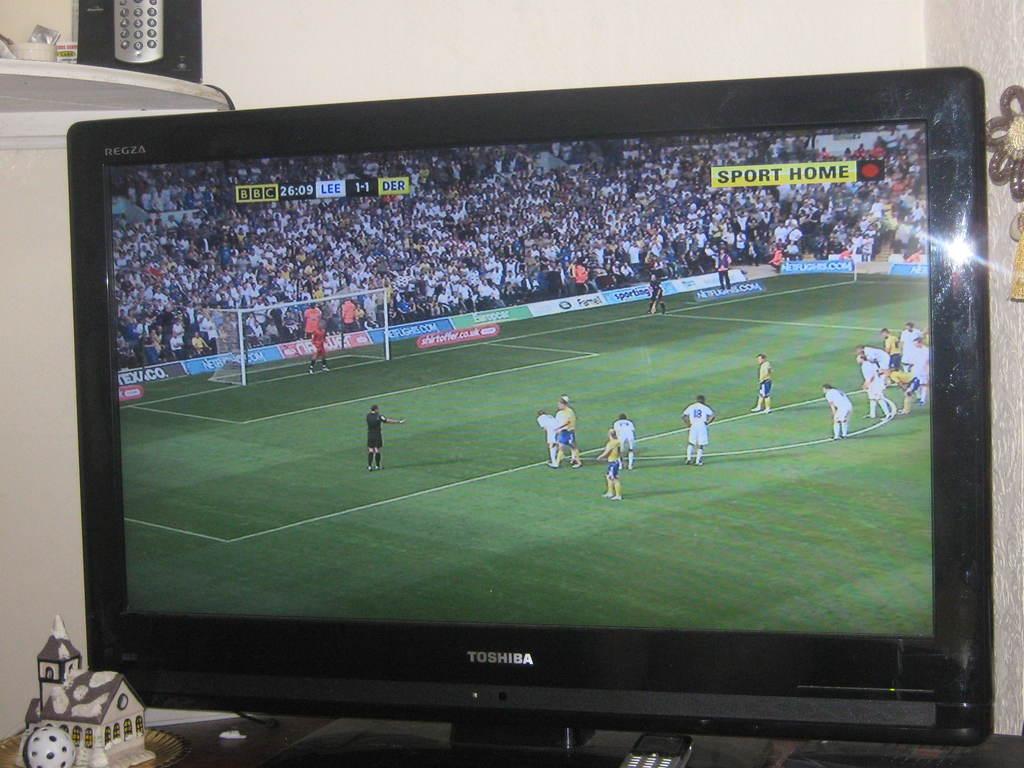What brand of tv is this?
Give a very brief answer. Toshiba. What channel are they watching?
Give a very brief answer. Sport home. 